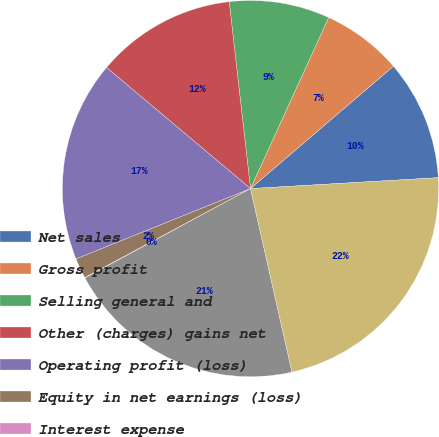Convert chart. <chart><loc_0><loc_0><loc_500><loc_500><pie_chart><fcel>Net sales<fcel>Gross profit<fcel>Selling general and<fcel>Other (charges) gains net<fcel>Operating profit (loss)<fcel>Equity in net earnings (loss)<fcel>Interest expense<fcel>Earnings (loss) from<fcel>Net earnings (loss)<nl><fcel>10.35%<fcel>6.91%<fcel>8.63%<fcel>12.07%<fcel>17.23%<fcel>1.75%<fcel>0.03%<fcel>20.67%<fcel>22.39%<nl></chart> 